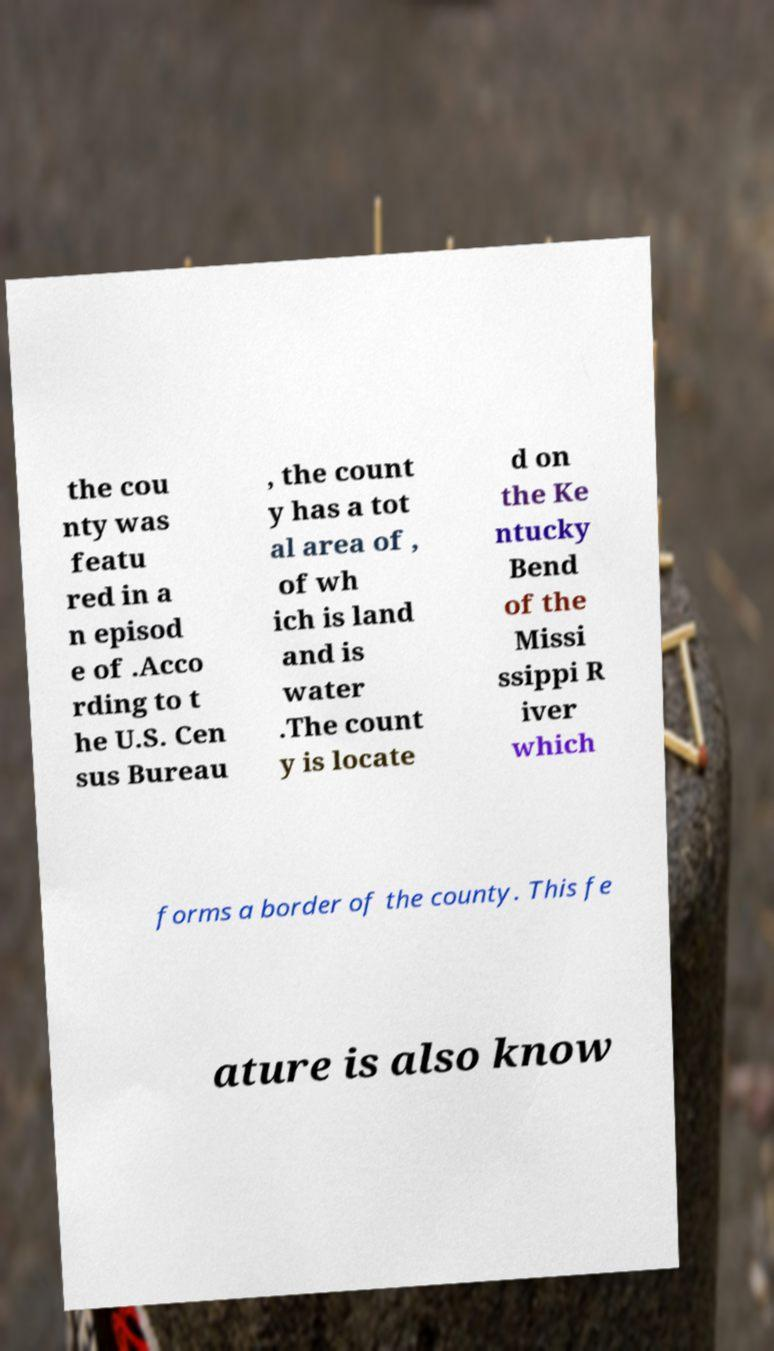Can you accurately transcribe the text from the provided image for me? the cou nty was featu red in a n episod e of .Acco rding to t he U.S. Cen sus Bureau , the count y has a tot al area of , of wh ich is land and is water .The count y is locate d on the Ke ntucky Bend of the Missi ssippi R iver which forms a border of the county. This fe ature is also know 